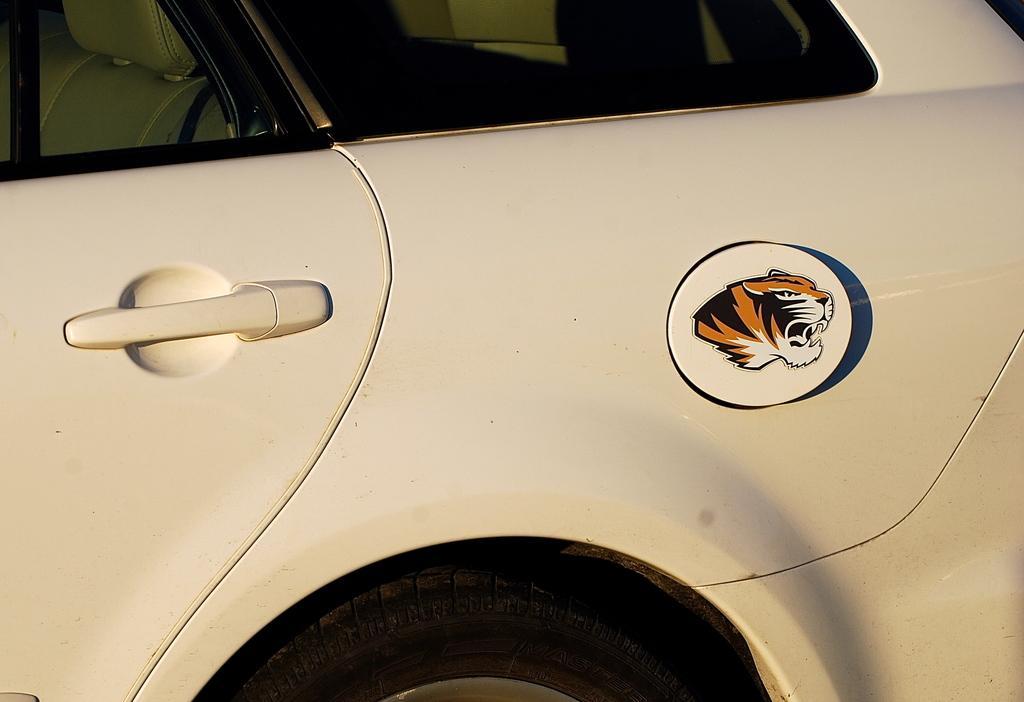In one or two sentences, can you explain what this image depicts? In this image there is a car. 